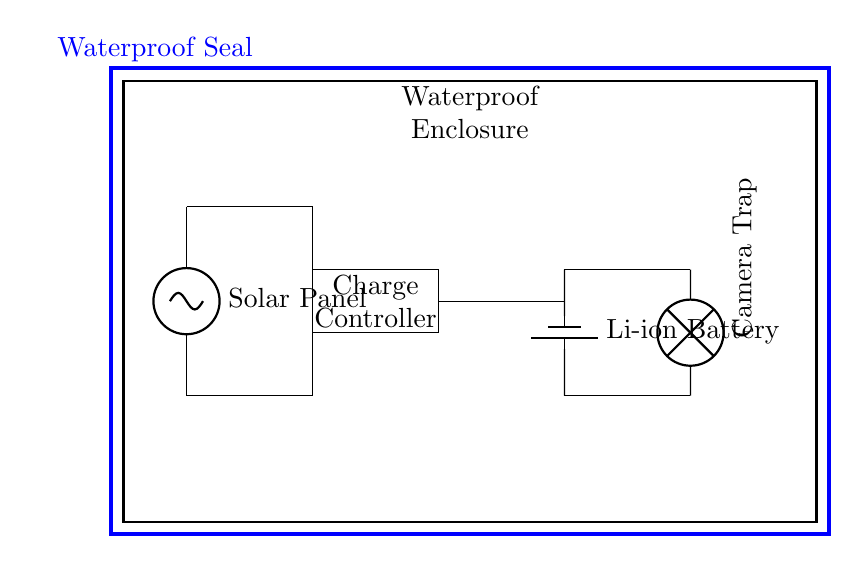What is the main energy source for the system? The main energy source is the solar panel, which harnesses sunlight to generate electricity. This is indicated by its connection at the top of the circuit diagram.
Answer: Solar panel What type of battery is used? The diagram indicates that a lithium-ion battery is used, as shown by the label next to the battery symbol in the circuit.
Answer: Li-ion Battery How many major components are in the circuit? The circuit contains four major components: a solar panel, charge controller, battery, and camera trap. These are clearly labeled within the waterproof enclosure.
Answer: Four What is the function of the charge controller? The charge controller regulates the charging of the battery by managing the voltage and current from the solar panel, ensuring that the battery is charged safely and efficiently. This is a common function in solar-powered systems.
Answer: Regulate charging What is indicated by the blue rectangle surrounding the circuit? The blue rectangle indicates a waterproof seal that protects the components from water intrusion, crucial for underwater use. It explicitly labels the enclosure as waterproof.
Answer: Waterproof seal How does the camera trap receive power? The camera trap receives power directly from the battery, which is connected to the camera trap output, as per the connections drawn in the circuit.
Answer: From the battery 